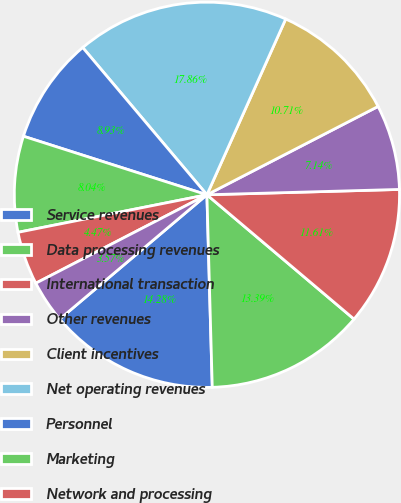Convert chart. <chart><loc_0><loc_0><loc_500><loc_500><pie_chart><fcel>Service revenues<fcel>Data processing revenues<fcel>International transaction<fcel>Other revenues<fcel>Client incentives<fcel>Net operating revenues<fcel>Personnel<fcel>Marketing<fcel>Network and processing<fcel>Professional fees<nl><fcel>14.28%<fcel>13.39%<fcel>11.61%<fcel>7.14%<fcel>10.71%<fcel>17.86%<fcel>8.93%<fcel>8.04%<fcel>4.47%<fcel>3.57%<nl></chart> 